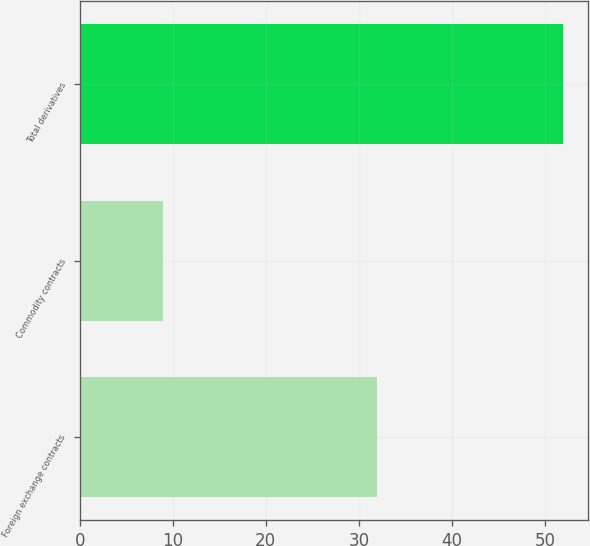<chart> <loc_0><loc_0><loc_500><loc_500><bar_chart><fcel>Foreign exchange contracts<fcel>Commodity contracts<fcel>Total derivatives<nl><fcel>32<fcel>9<fcel>52<nl></chart> 